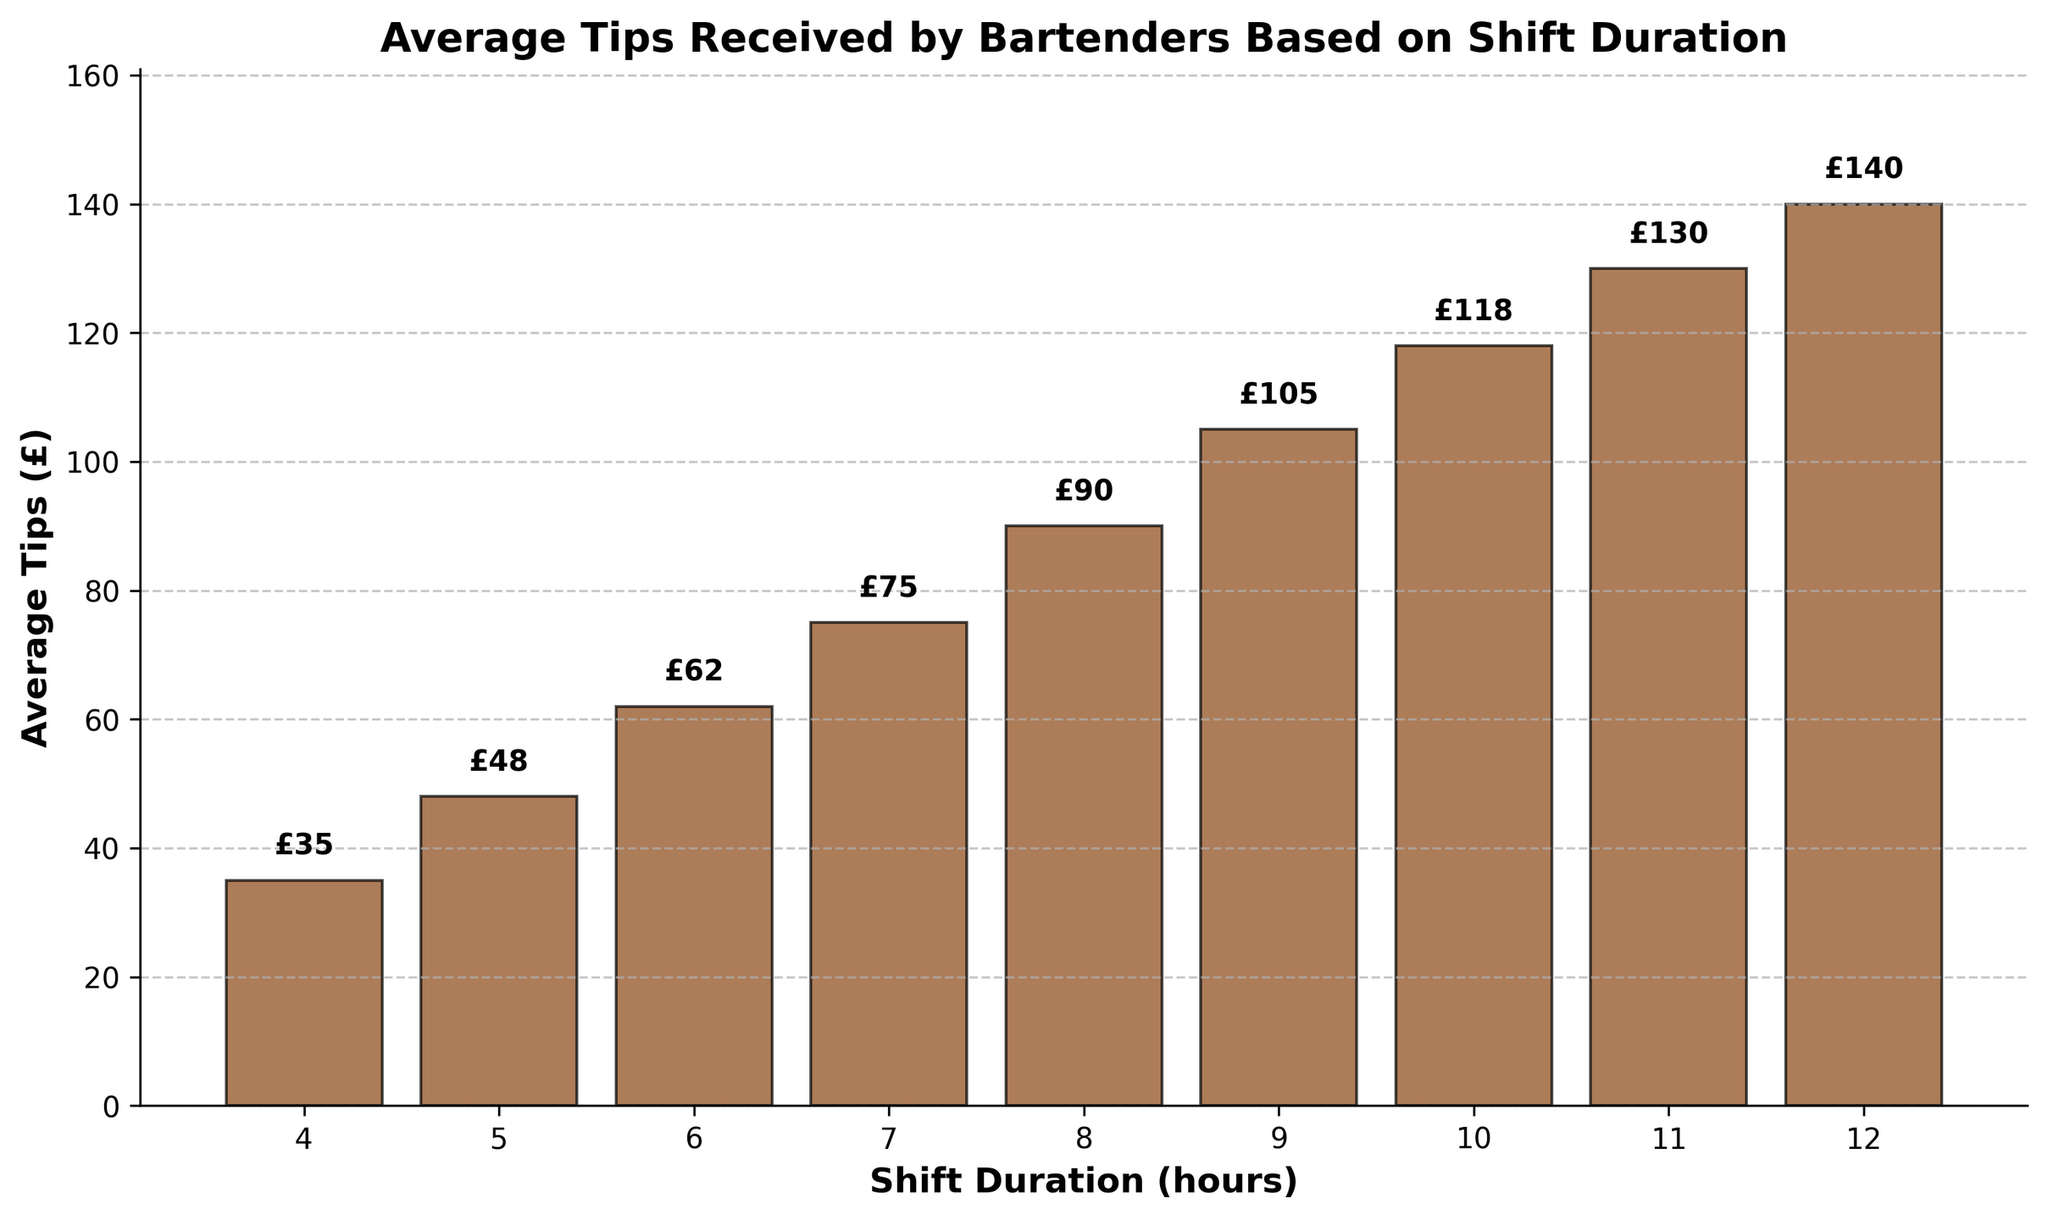What's the title of the figure? The title appears at the top of the figure and is meant to describe what the chart represents. In this case, the title is clearly displayed.
Answer: Average Tips Received by Bartenders Based on Shift Duration How many bars are plotted in the figure? To find out the number of data points, count the bars in the chart, each representing a shift duration.
Answer: 9 What is the average tip amount for a 6-hour shift? Locate the bar that corresponds to the 6-hour shift and read the value at the top of the bar.
Answer: £62 Which shift duration receives the highest average tips? Scan the bars to find the tallest one, which represents the highest average tips.
Answer: 12-hour shift What is the difference in average tips between a 4-hour shift and a 12-hour shift? Find the tip amounts for both shift durations (£35 for 4-hour and £140 for 12-hour), then subtract the smaller amount from the larger one.
Answer: £105 How does the average tip amount change as shift duration increases from 4 hours to 12 hours? Observe the trend of the bars as the x-values (shift durations) increase. Note that the average tips consistently increase.
Answer: Increasing What is the percentage increase in average tips from an 8-hour shift to a 10-hour shift? Calculate the absolute increase (118 - 90 = 28), then divide by the 8-hour shift's average (28 / 90) and multiply by 100 to convert to a percentage.
Answer: 31.11% Which two consecutive shift durations have the smallest increase in average tips? Examine the differences in average tips for every pair of consecutive shift durations and identify the smallest one. The smallest increase is between 11 hours (£130) and 12 hours (£140), which is £10.
Answer: 11-hour and 12-hour How does the color and style of the bars help interpret the figure? The bars are colored in brown with black edges, making them distinctive and easy to compare. The grid lines provide reference points for better reading values. This color and style help to highlight and differentiate each bar clearly.
Answer: Distinct colors and grid lines What do the labels above each bar represent, and why are they important? Each label shows the exact average tip amount for that particular shift duration, which helps the viewer quickly identify specific values without approximating from the bar heights.
Answer: Exact average tips 